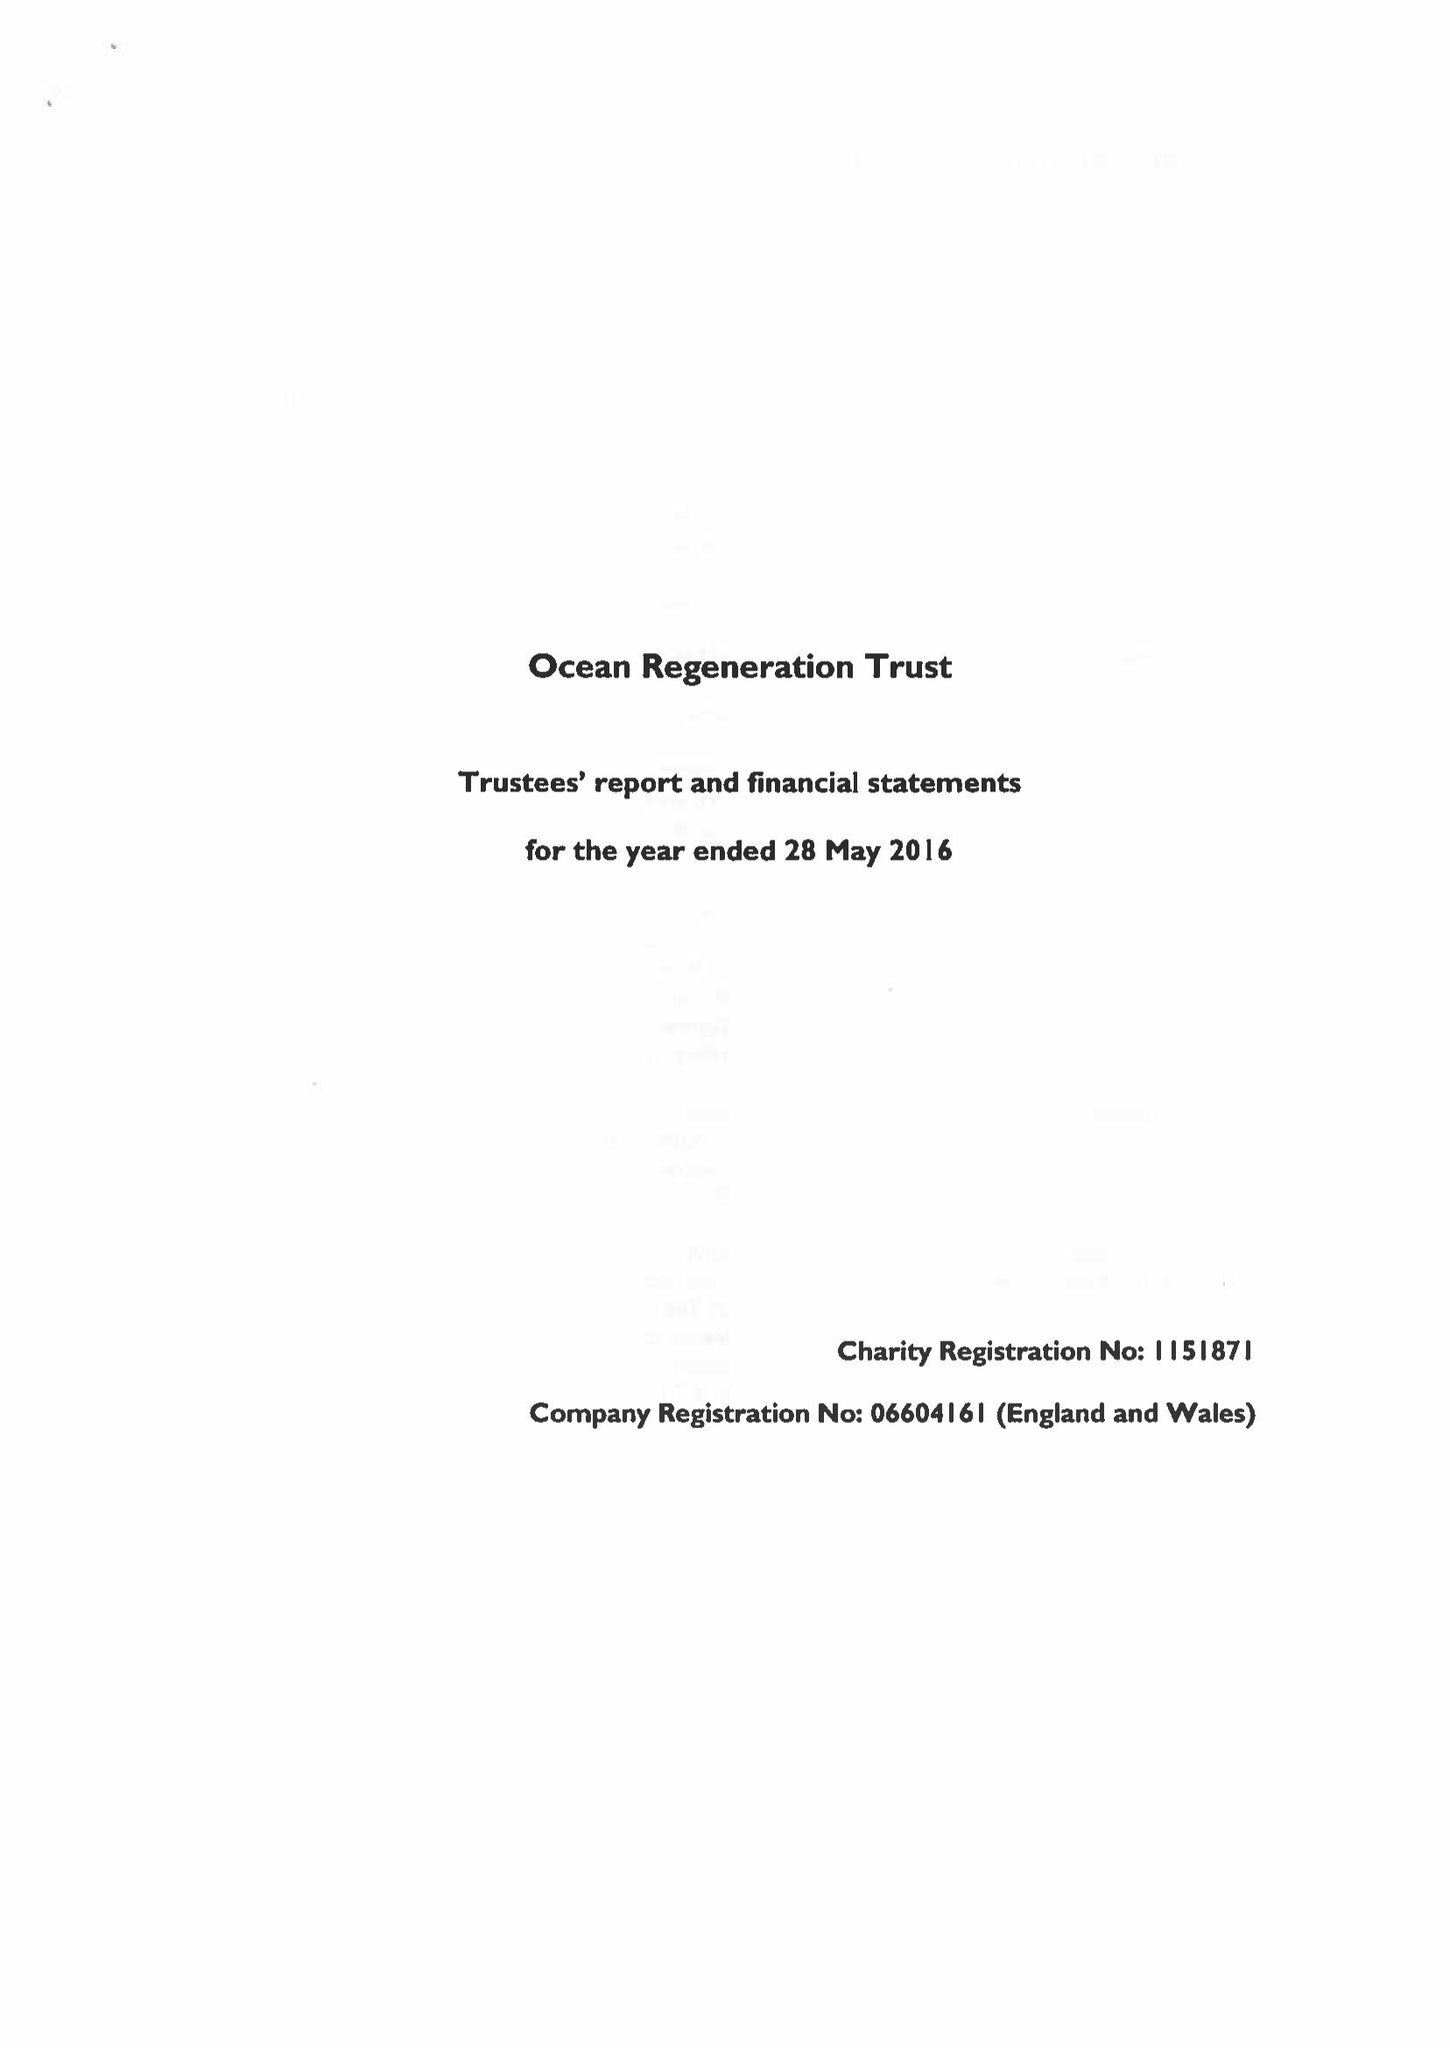What is the value for the address__street_line?
Answer the question using a single word or phrase. 115 HARFORD STREET 